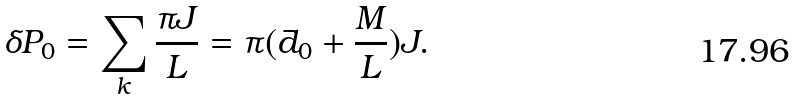Convert formula to latex. <formula><loc_0><loc_0><loc_500><loc_500>\delta P _ { 0 } = \sum _ { k } \frac { \pi J } { L } = \pi ( \bar { d } _ { 0 } + \frac { M } { L } ) J .</formula> 